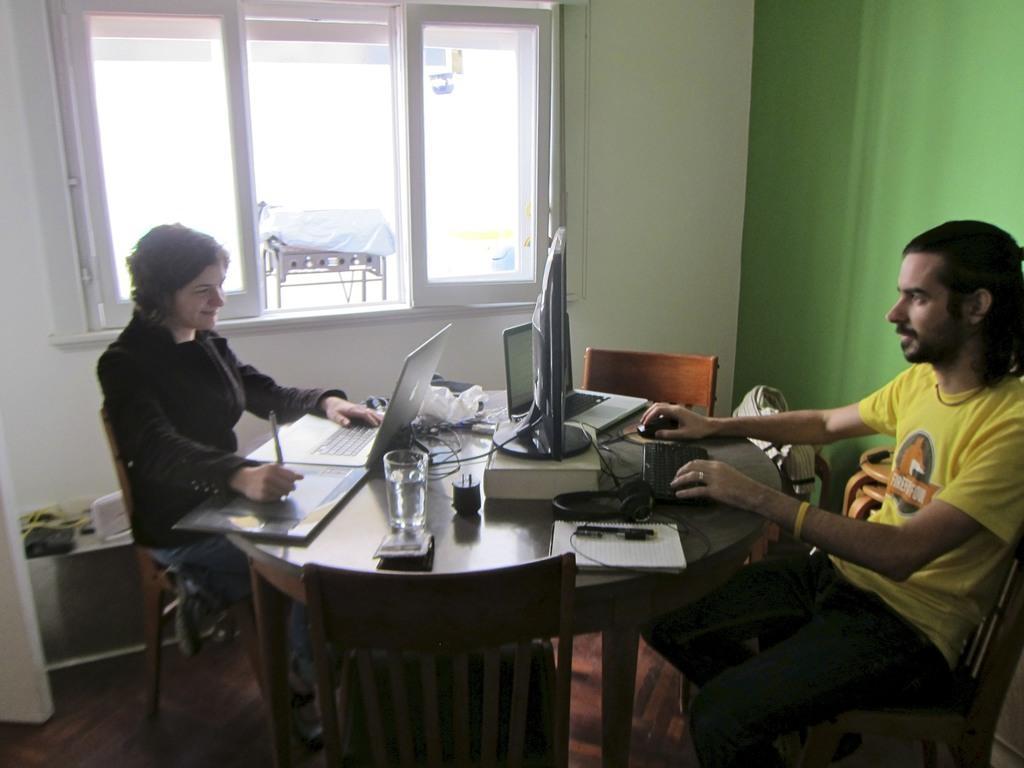Could you give a brief overview of what you see in this image? In this image there are two persons sitting and looking to the computer. There are wires, computers, pens, paper and glass on the table. At the back there is a window. 